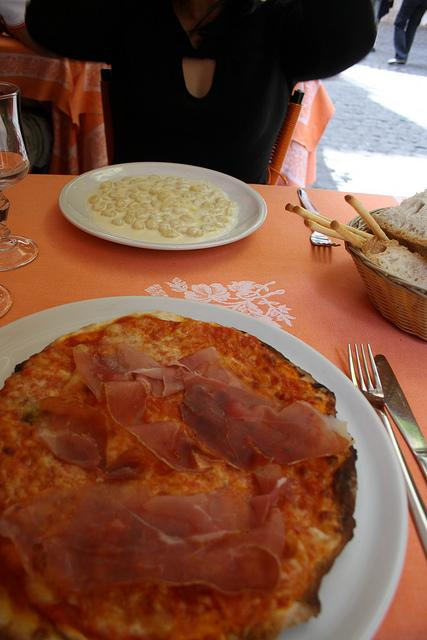What are the sticks seen here made from? wood 